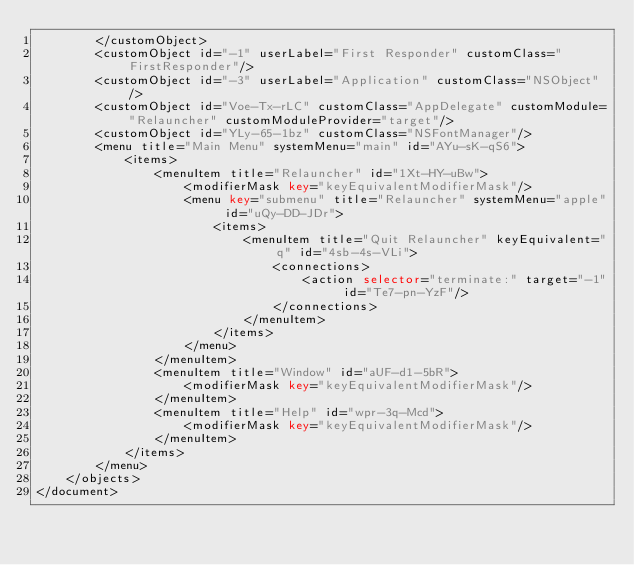<code> <loc_0><loc_0><loc_500><loc_500><_XML_>        </customObject>
        <customObject id="-1" userLabel="First Responder" customClass="FirstResponder"/>
        <customObject id="-3" userLabel="Application" customClass="NSObject"/>
        <customObject id="Voe-Tx-rLC" customClass="AppDelegate" customModule="Relauncher" customModuleProvider="target"/>
        <customObject id="YLy-65-1bz" customClass="NSFontManager"/>
        <menu title="Main Menu" systemMenu="main" id="AYu-sK-qS6">
            <items>
                <menuItem title="Relauncher" id="1Xt-HY-uBw">
                    <modifierMask key="keyEquivalentModifierMask"/>
                    <menu key="submenu" title="Relauncher" systemMenu="apple" id="uQy-DD-JDr">
                        <items>
                            <menuItem title="Quit Relauncher" keyEquivalent="q" id="4sb-4s-VLi">
                                <connections>
                                    <action selector="terminate:" target="-1" id="Te7-pn-YzF"/>
                                </connections>
                            </menuItem>
                        </items>
                    </menu>
                </menuItem>
                <menuItem title="Window" id="aUF-d1-5bR">
                    <modifierMask key="keyEquivalentModifierMask"/>
                </menuItem>
                <menuItem title="Help" id="wpr-3q-Mcd">
                    <modifierMask key="keyEquivalentModifierMask"/>
                </menuItem>
            </items>
        </menu>
    </objects>
</document>
</code> 